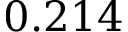<formula> <loc_0><loc_0><loc_500><loc_500>0 . 2 1 4</formula> 